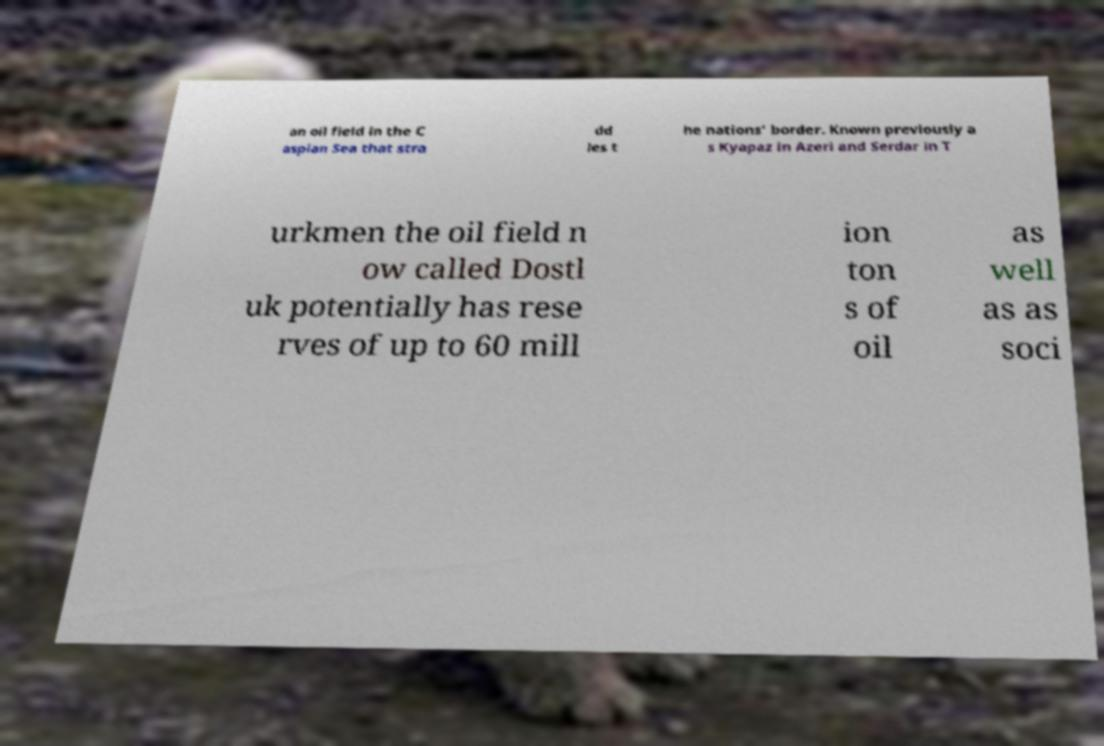There's text embedded in this image that I need extracted. Can you transcribe it verbatim? an oil field in the C aspian Sea that stra dd les t he nations' border. Known previously a s Kyapaz in Azeri and Serdar in T urkmen the oil field n ow called Dostl uk potentially has rese rves of up to 60 mill ion ton s of oil as well as as soci 